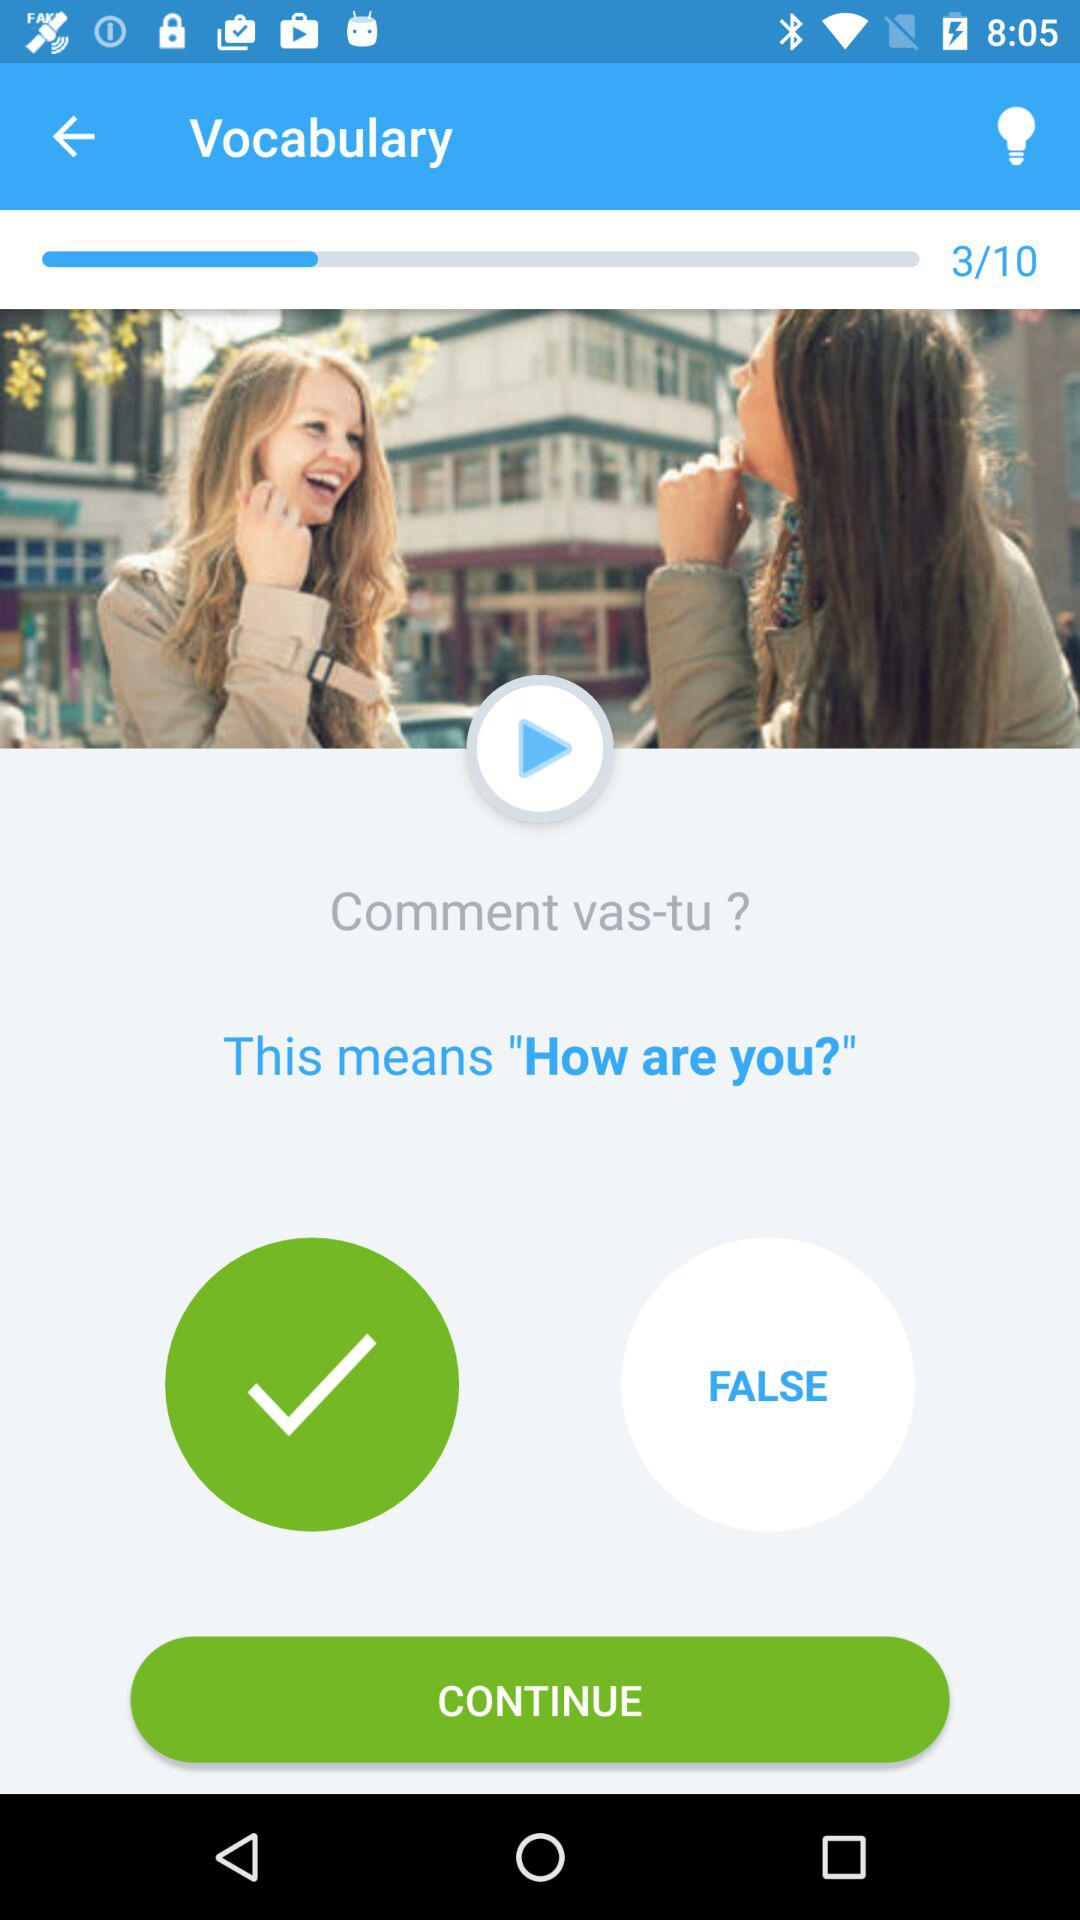How many questions in total are there in "Vocabulary"? There are 10 questions in "Vocabulary". 